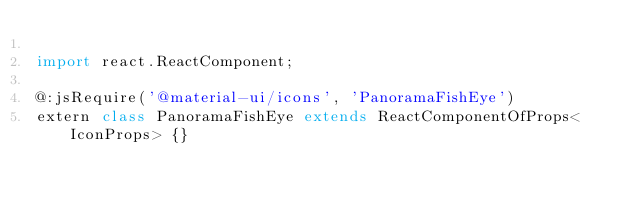<code> <loc_0><loc_0><loc_500><loc_500><_Haxe_>
import react.ReactComponent;

@:jsRequire('@material-ui/icons', 'PanoramaFishEye')
extern class PanoramaFishEye extends ReactComponentOfProps<IconProps> {}
</code> 